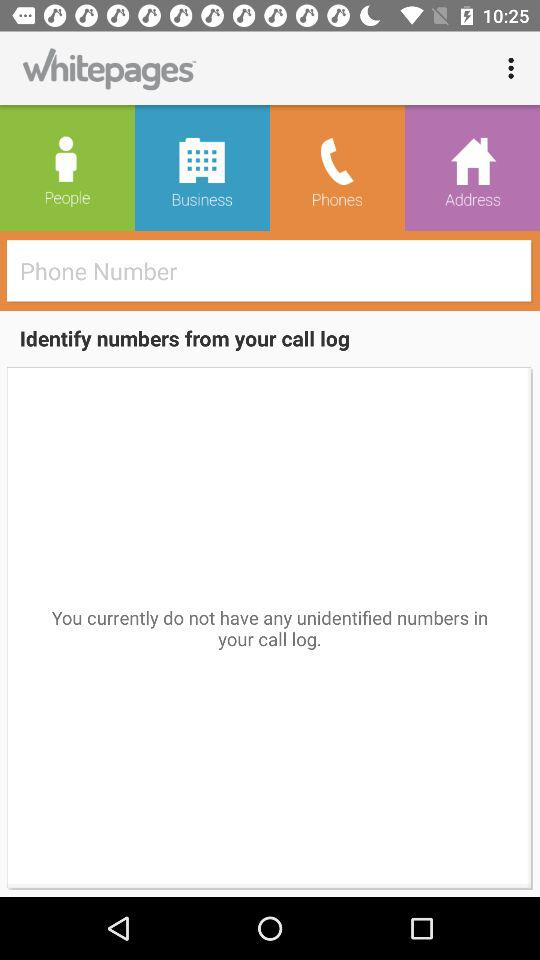Are there any unidentified numbers in the call log? There are no unidentified numbers in the call log. 